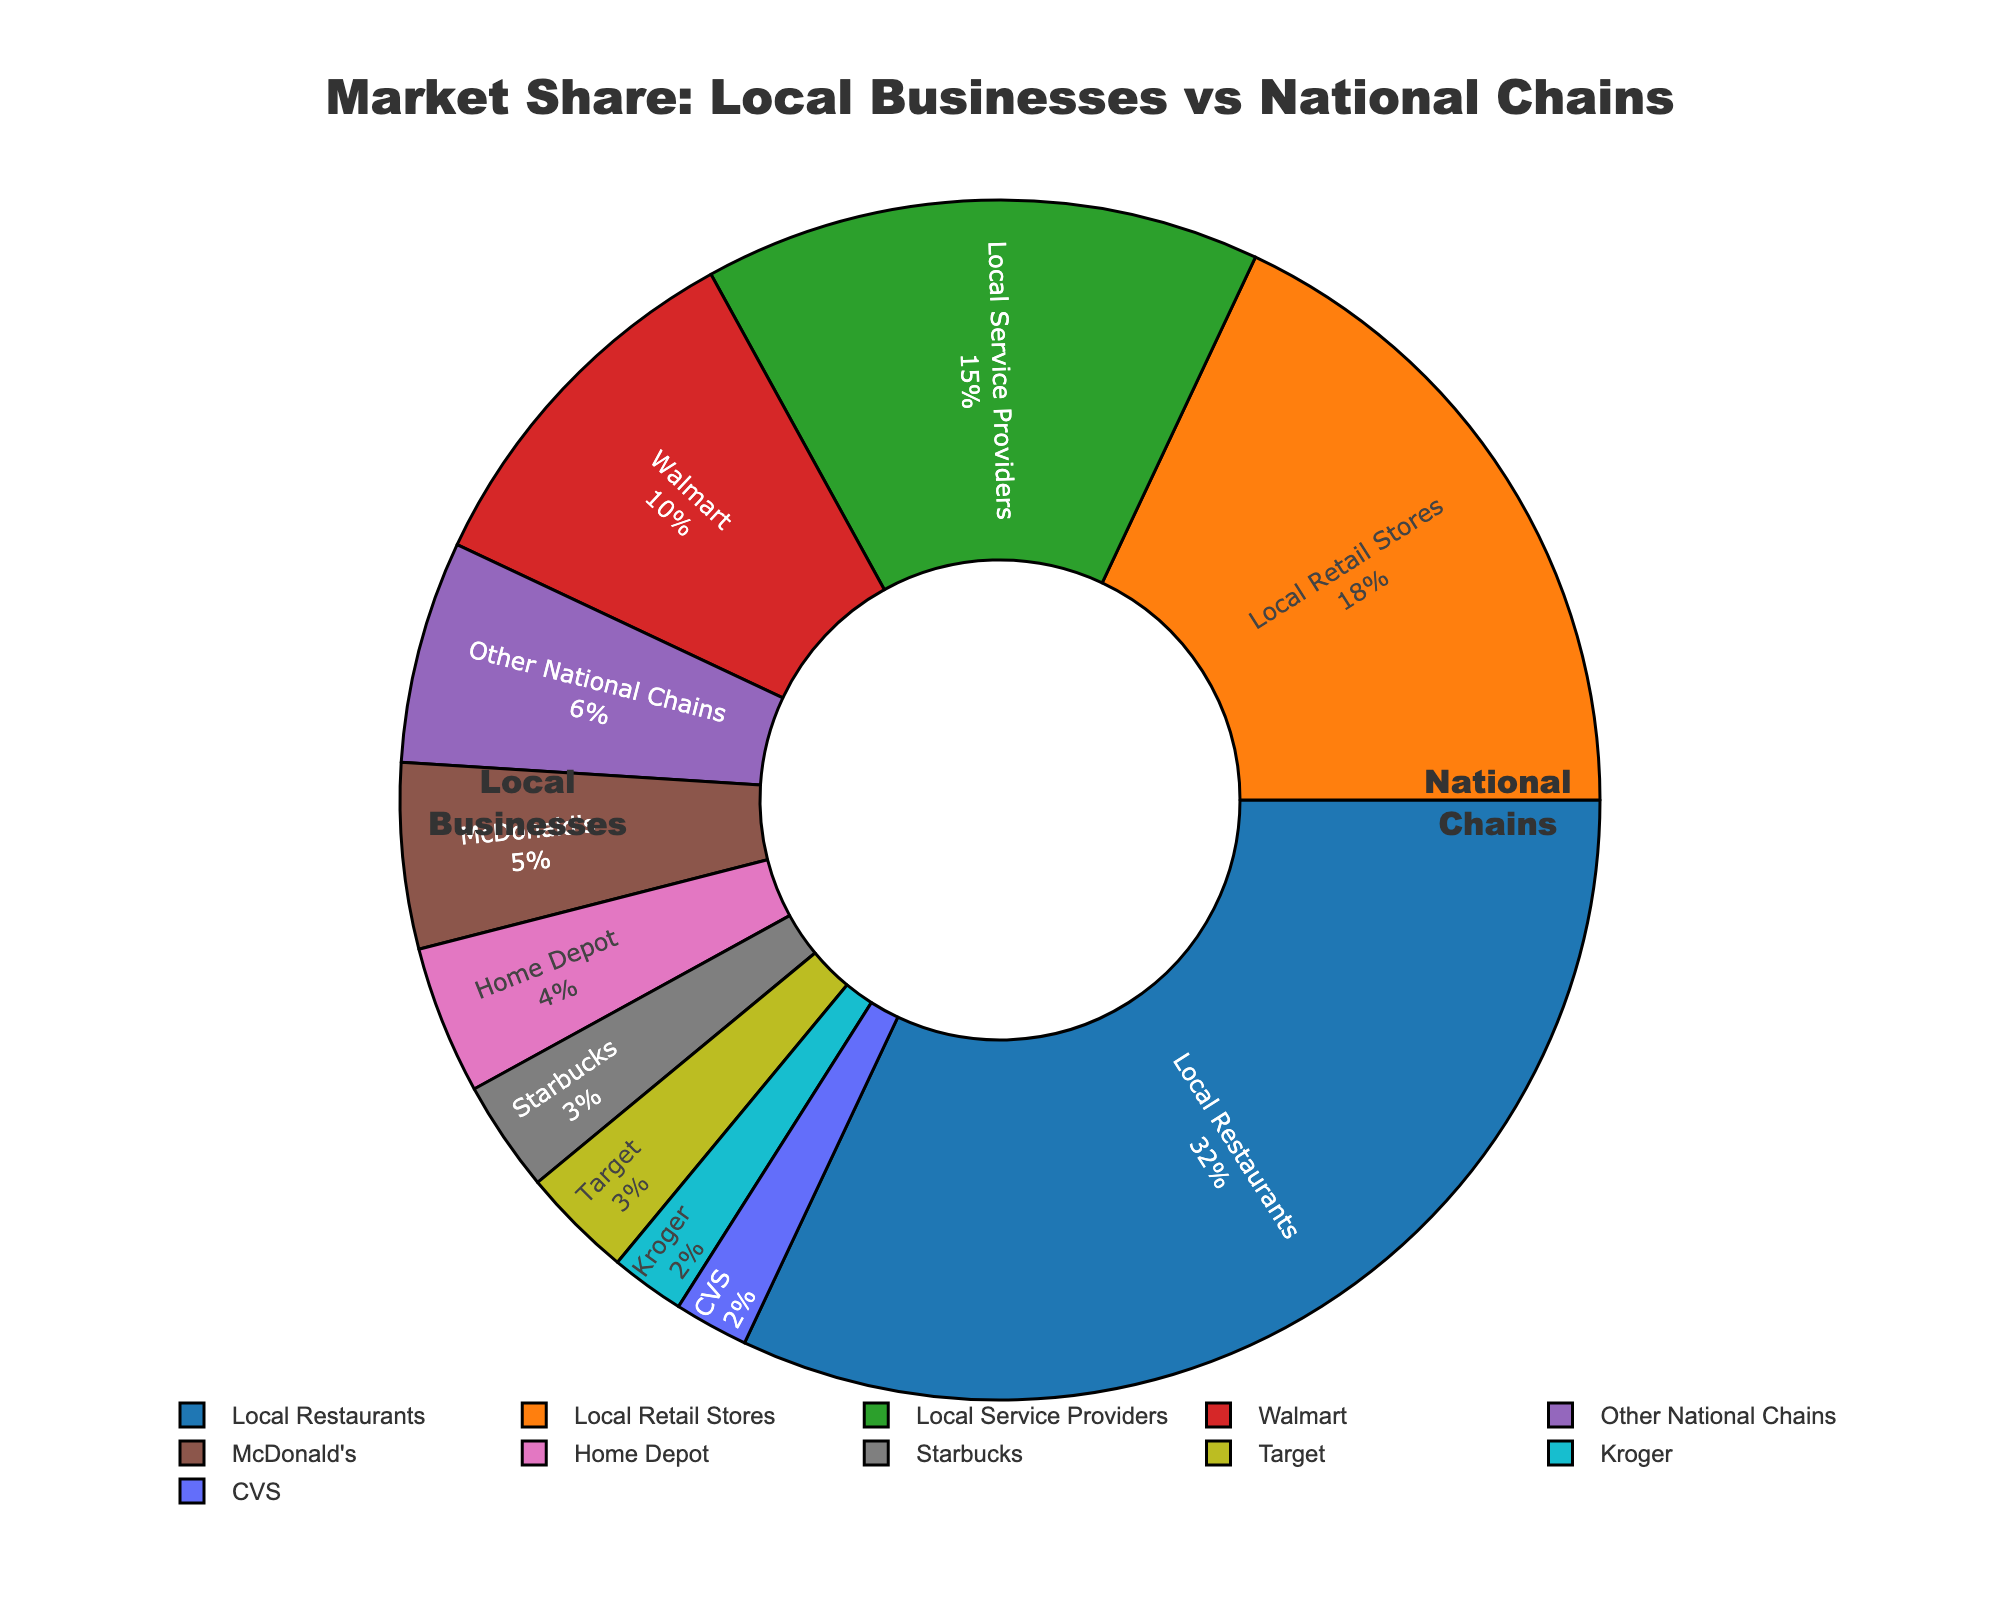Which business type has the highest market share? By looking at the figure, identify the largest slice of the pie chart. The largest slice is labeled as "Local Restaurants" with 32% market share.
Answer: Local Restaurants How much more market share do local restaurants have compared to Walmart? Local Restaurants have a market share of 32%, and Walmart has a market share of 10%. The difference is calculated as 32% - 10%.
Answer: 22% What is the combined market share of local retail stores and McDonald's? Local Retail Stores have a market share of 18%, and McDonald's has 5%. The combined market share is 18% + 5%.
Answer: 23% Which national chain has the smallest market share? Looking at the labeled slices for national chains, identify which has the smallest percentage. Kroger and CVS both have 2%, making them the smallest.
Answer: Kroger or CVS What percentage of the market is controlled by national chains? Add up the market share percentages for all national chains (Walmart, McDonald's, Home Depot, Starbucks, Target, Kroger, CVS, and Other National Chains). The sum is 10% + 5% + 4% + 3% + 3% + 2% + 2% + 6%.
Answer: 35% How does the market share of local service providers compare to that of Home Depot and Starbucks combined? Local Service Providers have a market share of 15%, while Home Depot and Starbucks combined have 4% + 3% = 7%. The difference is 15% - 7%.
Answer: 8% higher What is the total market share of all local businesses? Add up the market shares of Local Restaurants (32%), Local Retail Stores (18%), and Local Service Providers (15%). The total is 32% + 18% + 15%.
Answer: 65% Which business type has the second-largest market share? Identify the business type with the second-largest slice in the pie chart. The second-largest is "Local Retail Stores" with 18%.
Answer: Local Retail Stores How much more market share do local businesses have compared to national chains? The total market share of local businesses is 65%, and for national chains, it is 35%. The difference is 65% - 35%.
Answer: 30% What is the difference in market share between the largest local business type and the largest national chain? Local Restaurants (32%) is the largest local business type. Walmart (10%) is the largest national chain. The difference is 32% - 10%.
Answer: 22% 